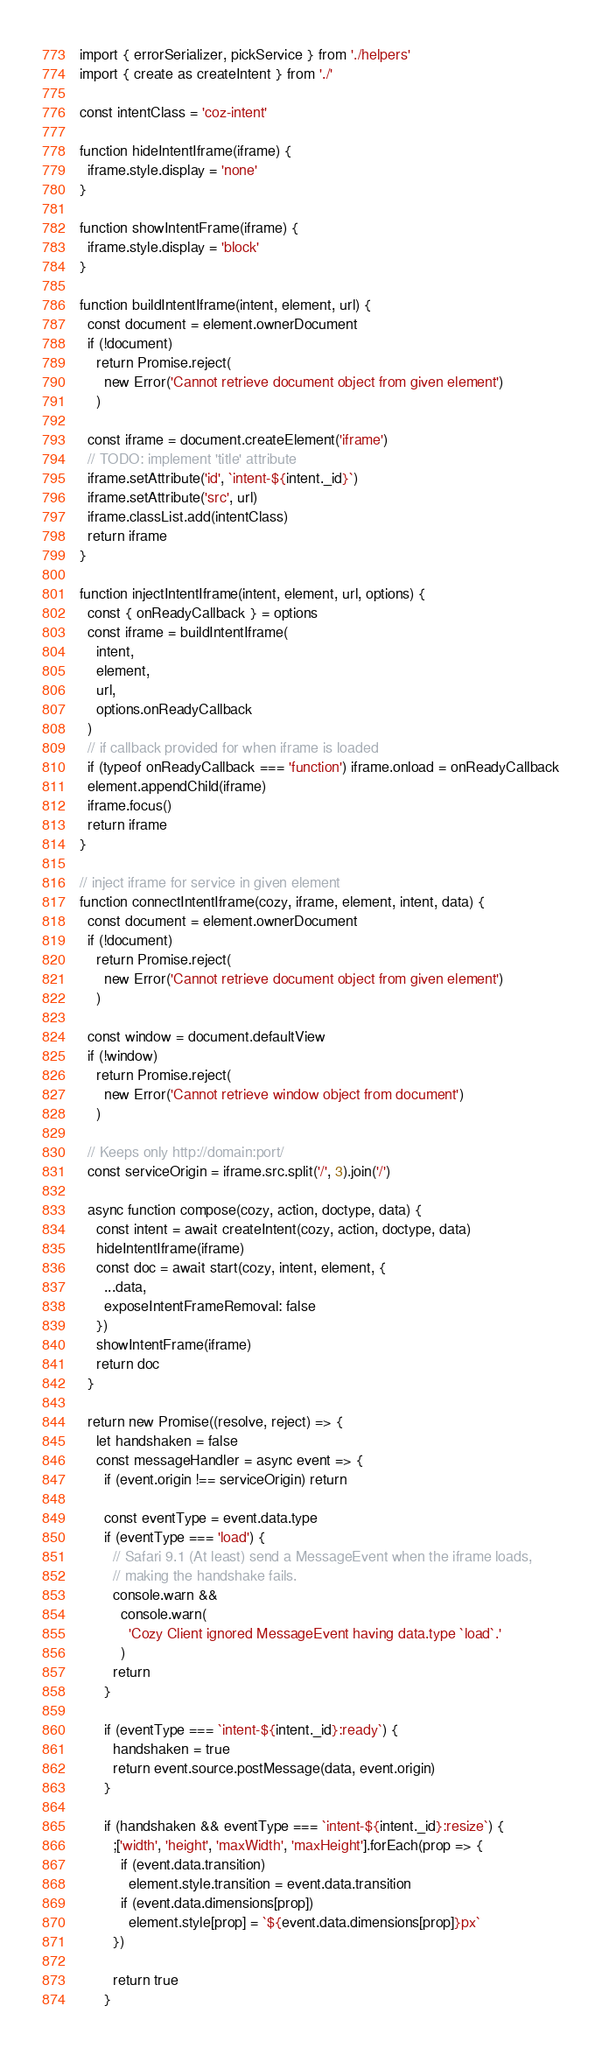Convert code to text. <code><loc_0><loc_0><loc_500><loc_500><_JavaScript_>import { errorSerializer, pickService } from './helpers'
import { create as createIntent } from './'

const intentClass = 'coz-intent'

function hideIntentIframe(iframe) {
  iframe.style.display = 'none'
}

function showIntentFrame(iframe) {
  iframe.style.display = 'block'
}

function buildIntentIframe(intent, element, url) {
  const document = element.ownerDocument
  if (!document)
    return Promise.reject(
      new Error('Cannot retrieve document object from given element')
    )

  const iframe = document.createElement('iframe')
  // TODO: implement 'title' attribute
  iframe.setAttribute('id', `intent-${intent._id}`)
  iframe.setAttribute('src', url)
  iframe.classList.add(intentClass)
  return iframe
}

function injectIntentIframe(intent, element, url, options) {
  const { onReadyCallback } = options
  const iframe = buildIntentIframe(
    intent,
    element,
    url,
    options.onReadyCallback
  )
  // if callback provided for when iframe is loaded
  if (typeof onReadyCallback === 'function') iframe.onload = onReadyCallback
  element.appendChild(iframe)
  iframe.focus()
  return iframe
}

// inject iframe for service in given element
function connectIntentIframe(cozy, iframe, element, intent, data) {
  const document = element.ownerDocument
  if (!document)
    return Promise.reject(
      new Error('Cannot retrieve document object from given element')
    )

  const window = document.defaultView
  if (!window)
    return Promise.reject(
      new Error('Cannot retrieve window object from document')
    )

  // Keeps only http://domain:port/
  const serviceOrigin = iframe.src.split('/', 3).join('/')

  async function compose(cozy, action, doctype, data) {
    const intent = await createIntent(cozy, action, doctype, data)
    hideIntentIframe(iframe)
    const doc = await start(cozy, intent, element, {
      ...data,
      exposeIntentFrameRemoval: false
    })
    showIntentFrame(iframe)
    return doc
  }

  return new Promise((resolve, reject) => {
    let handshaken = false
    const messageHandler = async event => {
      if (event.origin !== serviceOrigin) return

      const eventType = event.data.type
      if (eventType === 'load') {
        // Safari 9.1 (At least) send a MessageEvent when the iframe loads,
        // making the handshake fails.
        console.warn &&
          console.warn(
            'Cozy Client ignored MessageEvent having data.type `load`.'
          )
        return
      }

      if (eventType === `intent-${intent._id}:ready`) {
        handshaken = true
        return event.source.postMessage(data, event.origin)
      }

      if (handshaken && eventType === `intent-${intent._id}:resize`) {
        ;['width', 'height', 'maxWidth', 'maxHeight'].forEach(prop => {
          if (event.data.transition)
            element.style.transition = event.data.transition
          if (event.data.dimensions[prop])
            element.style[prop] = `${event.data.dimensions[prop]}px`
        })

        return true
      }
</code> 